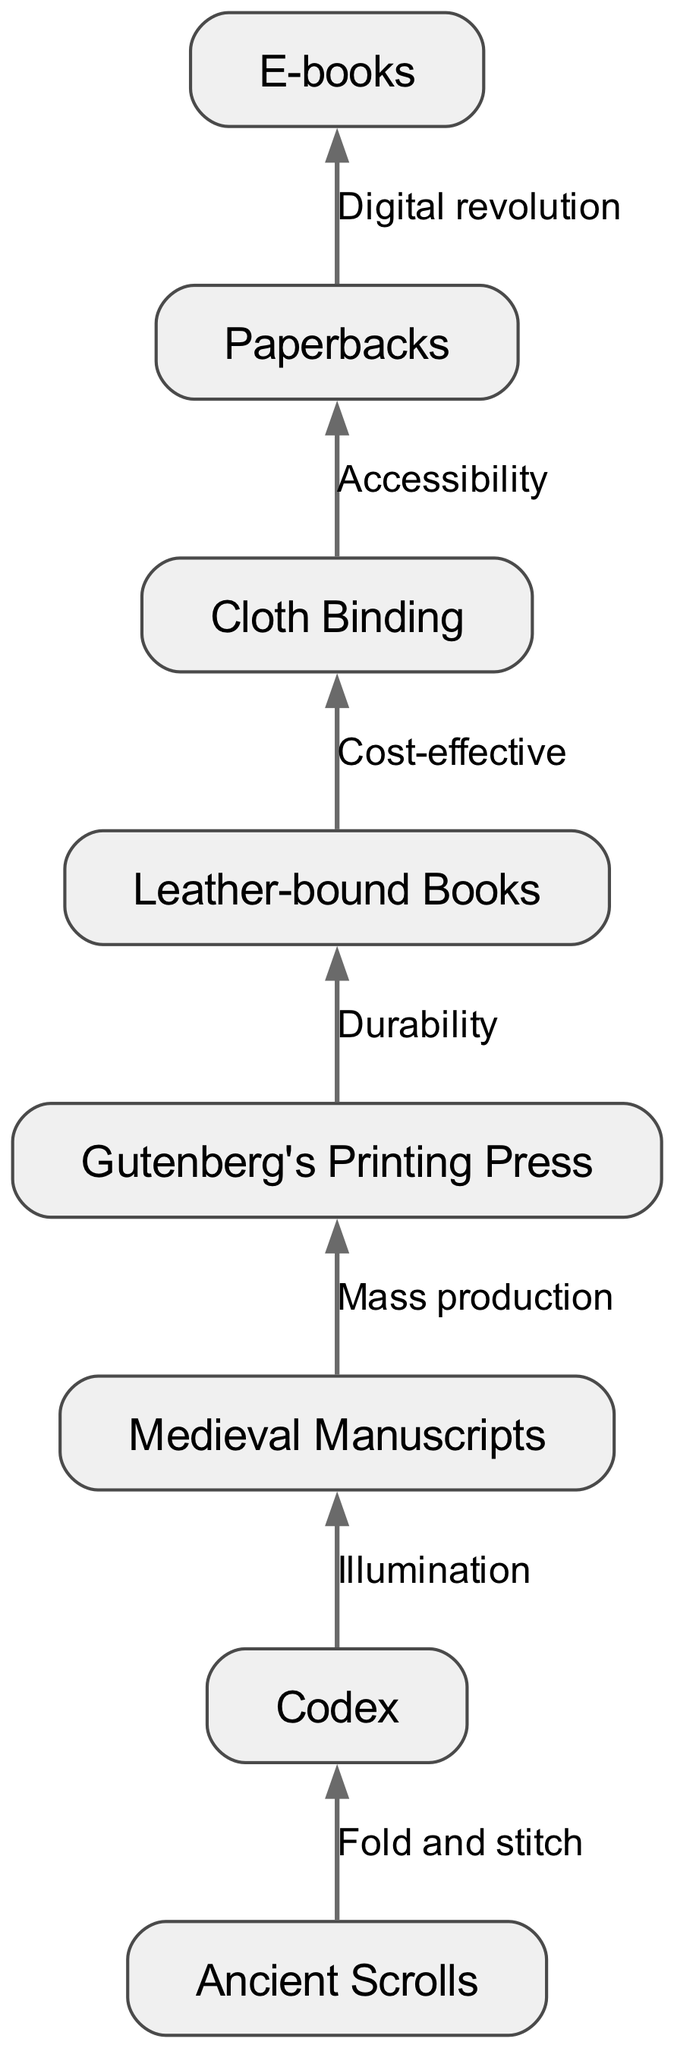What is the first node in the flow chart? The first node represents the earliest form of book binding, which is "Ancient Scrolls." It is the starting point of the flow chart, indicating the initial method of recording and storing written information.
Answer: Ancient Scrolls How many nodes are in the diagram? To find the total number of nodes, we can count each entry in the node section of the provided data. There are eight distinct nodes listed in the diagram, representing key stages in book binding evolution.
Answer: 8 What edge connects "Codex" and "Medieval Manuscripts"? The edge that connects "Codex" to "Medieval Manuscripts" indicates the concept of "Illumination." It describes a process or technique associated with that transition from one form to another in the evolution of book binding.
Answer: Illumination Which node follows "Gutenberg's Printing Press"? The node that follows "Gutenberg's Printing Press" in the flow is "Leather-bound Books." This connection signifies the advancement in book durability due to the innovations introduced by the printing press.
Answer: Leather-bound Books What relationship connects "E-books" to "Paperbacks"? The relationship connecting "E-books" to "Paperbacks" is described by "Digital revolution." This shows the evolution from physical forms of books to digital formats, indicating how technology has transformed accessibility to literature.
Answer: Digital revolution What is the primary method used to create a "Codex"? The primary method listed for creating a "Codex" is "Fold and stitch." This technique is fundamental to how early codices were constructed, combining sheets to form a book format.
Answer: Fold and stitch How does "Leather-bound Books" transition to "Cloth Binding"? The transition from "Leather-bound Books" to "Cloth Binding" is based on the principle of "Cost-effective." This indicates a shift towards materials and techniques that reduced production costs while maintaining quality.
Answer: Cost-effective What is the last node in the flow chart? The last node in the flow chart represents the latest form of book binding techniques, which is "E-books." This indicates the culmination of the evolution process presented in the diagram from ancient to modern formats.
Answer: E-books How is "Accessibility" related to "Cloth Binding"? The relationship is indicated by the edge labeled "Accessibility," which connects "Cloth Binding" and "Paperbacks." It emphasizes how cloth-bound books became more accessible to a wider audience through their affordable production.
Answer: Accessibility 